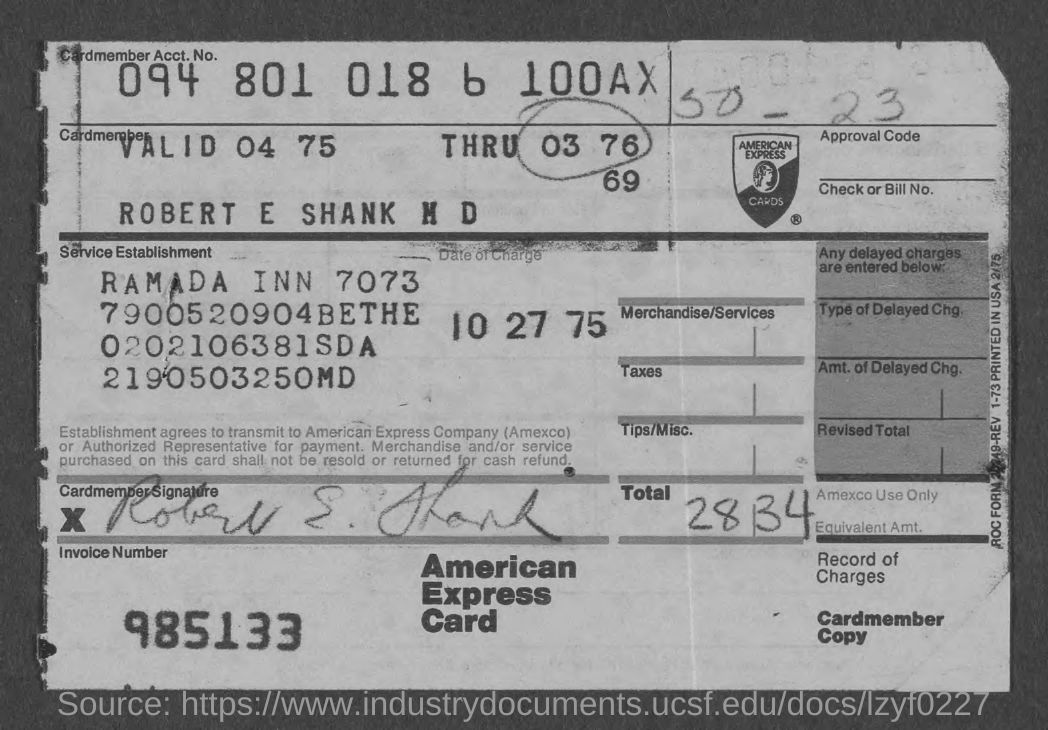What is the cardmember acct. no.?
Your answer should be compact. 094 801 018 6 100AX. What is the date of charge?
Keep it short and to the point. 10 27 75. What is the invoice number ?
Your response must be concise. 985133. 